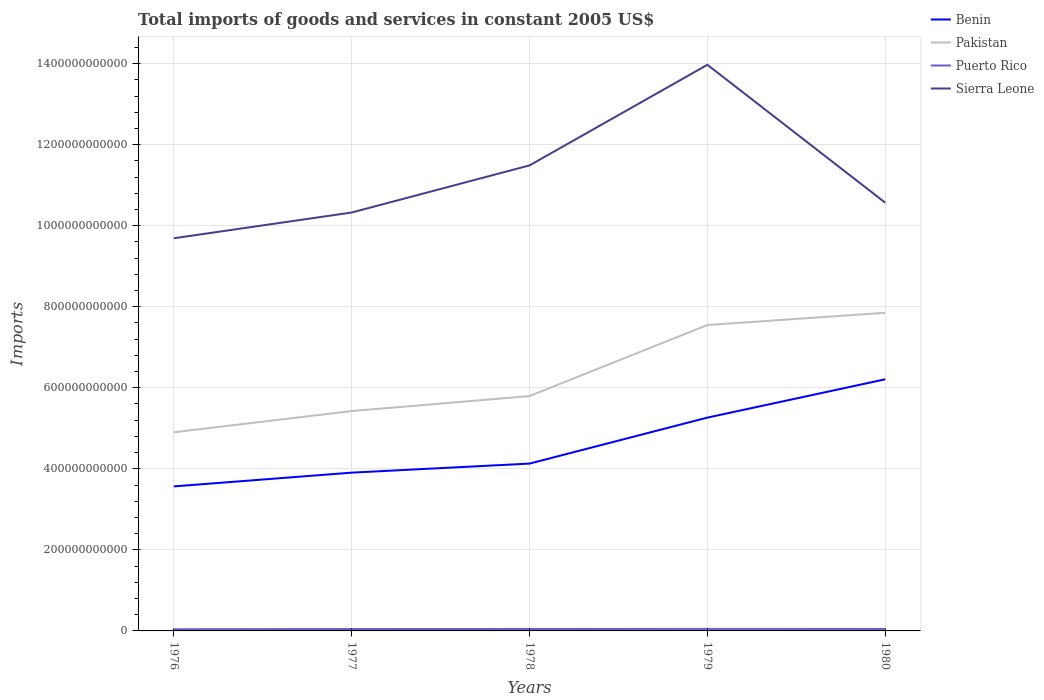How many different coloured lines are there?
Your response must be concise. 4. Does the line corresponding to Puerto Rico intersect with the line corresponding to Benin?
Offer a terse response. No. Is the number of lines equal to the number of legend labels?
Offer a terse response. Yes. Across all years, what is the maximum total imports of goods and services in Sierra Leone?
Ensure brevity in your answer.  9.69e+11. In which year was the total imports of goods and services in Pakistan maximum?
Your response must be concise. 1976. What is the total total imports of goods and services in Pakistan in the graph?
Keep it short and to the point. -2.43e+11. What is the difference between the highest and the second highest total imports of goods and services in Pakistan?
Keep it short and to the point. 2.95e+11. What is the difference between two consecutive major ticks on the Y-axis?
Provide a succinct answer. 2.00e+11. Are the values on the major ticks of Y-axis written in scientific E-notation?
Give a very brief answer. No. Does the graph contain any zero values?
Your answer should be very brief. No. Does the graph contain grids?
Offer a terse response. Yes. Where does the legend appear in the graph?
Make the answer very short. Top right. How many legend labels are there?
Your answer should be compact. 4. What is the title of the graph?
Ensure brevity in your answer.  Total imports of goods and services in constant 2005 US$. What is the label or title of the X-axis?
Your answer should be compact. Years. What is the label or title of the Y-axis?
Keep it short and to the point. Imports. What is the Imports in Benin in 1976?
Provide a short and direct response. 3.57e+11. What is the Imports of Pakistan in 1976?
Offer a very short reply. 4.90e+11. What is the Imports of Puerto Rico in 1976?
Provide a succinct answer. 4.13e+09. What is the Imports of Sierra Leone in 1976?
Provide a short and direct response. 9.69e+11. What is the Imports of Benin in 1977?
Provide a succinct answer. 3.91e+11. What is the Imports in Pakistan in 1977?
Your response must be concise. 5.43e+11. What is the Imports in Puerto Rico in 1977?
Offer a very short reply. 4.71e+09. What is the Imports in Sierra Leone in 1977?
Your answer should be compact. 1.03e+12. What is the Imports of Benin in 1978?
Ensure brevity in your answer.  4.13e+11. What is the Imports of Pakistan in 1978?
Provide a succinct answer. 5.80e+11. What is the Imports of Puerto Rico in 1978?
Offer a terse response. 4.79e+09. What is the Imports in Sierra Leone in 1978?
Keep it short and to the point. 1.15e+12. What is the Imports of Benin in 1979?
Ensure brevity in your answer.  5.26e+11. What is the Imports in Pakistan in 1979?
Provide a succinct answer. 7.55e+11. What is the Imports in Puerto Rico in 1979?
Make the answer very short. 5.01e+09. What is the Imports of Sierra Leone in 1979?
Provide a succinct answer. 1.40e+12. What is the Imports of Benin in 1980?
Your answer should be compact. 6.21e+11. What is the Imports of Pakistan in 1980?
Your answer should be very brief. 7.85e+11. What is the Imports in Puerto Rico in 1980?
Give a very brief answer. 4.88e+09. What is the Imports of Sierra Leone in 1980?
Your response must be concise. 1.06e+12. Across all years, what is the maximum Imports of Benin?
Your response must be concise. 6.21e+11. Across all years, what is the maximum Imports in Pakistan?
Your answer should be compact. 7.85e+11. Across all years, what is the maximum Imports in Puerto Rico?
Offer a terse response. 5.01e+09. Across all years, what is the maximum Imports in Sierra Leone?
Provide a succinct answer. 1.40e+12. Across all years, what is the minimum Imports in Benin?
Your response must be concise. 3.57e+11. Across all years, what is the minimum Imports in Pakistan?
Make the answer very short. 4.90e+11. Across all years, what is the minimum Imports of Puerto Rico?
Keep it short and to the point. 4.13e+09. Across all years, what is the minimum Imports in Sierra Leone?
Make the answer very short. 9.69e+11. What is the total Imports in Benin in the graph?
Your response must be concise. 2.31e+12. What is the total Imports of Pakistan in the graph?
Your answer should be very brief. 3.15e+12. What is the total Imports in Puerto Rico in the graph?
Your answer should be very brief. 2.35e+1. What is the total Imports of Sierra Leone in the graph?
Provide a short and direct response. 5.60e+12. What is the difference between the Imports in Benin in 1976 and that in 1977?
Provide a succinct answer. -3.39e+1. What is the difference between the Imports in Pakistan in 1976 and that in 1977?
Ensure brevity in your answer.  -5.23e+1. What is the difference between the Imports in Puerto Rico in 1976 and that in 1977?
Give a very brief answer. -5.82e+08. What is the difference between the Imports of Sierra Leone in 1976 and that in 1977?
Provide a short and direct response. -6.35e+1. What is the difference between the Imports in Benin in 1976 and that in 1978?
Make the answer very short. -5.63e+1. What is the difference between the Imports in Pakistan in 1976 and that in 1978?
Offer a very short reply. -8.93e+1. What is the difference between the Imports of Puerto Rico in 1976 and that in 1978?
Your response must be concise. -6.62e+08. What is the difference between the Imports of Sierra Leone in 1976 and that in 1978?
Keep it short and to the point. -1.80e+11. What is the difference between the Imports of Benin in 1976 and that in 1979?
Offer a very short reply. -1.70e+11. What is the difference between the Imports in Pakistan in 1976 and that in 1979?
Offer a terse response. -2.65e+11. What is the difference between the Imports in Puerto Rico in 1976 and that in 1979?
Offer a terse response. -8.77e+08. What is the difference between the Imports in Sierra Leone in 1976 and that in 1979?
Your answer should be very brief. -4.28e+11. What is the difference between the Imports in Benin in 1976 and that in 1980?
Provide a succinct answer. -2.64e+11. What is the difference between the Imports of Pakistan in 1976 and that in 1980?
Offer a very short reply. -2.95e+11. What is the difference between the Imports of Puerto Rico in 1976 and that in 1980?
Give a very brief answer. -7.54e+08. What is the difference between the Imports of Sierra Leone in 1976 and that in 1980?
Offer a very short reply. -8.78e+1. What is the difference between the Imports in Benin in 1977 and that in 1978?
Your answer should be very brief. -2.23e+1. What is the difference between the Imports in Pakistan in 1977 and that in 1978?
Provide a short and direct response. -3.70e+1. What is the difference between the Imports in Puerto Rico in 1977 and that in 1978?
Your answer should be very brief. -7.99e+07. What is the difference between the Imports of Sierra Leone in 1977 and that in 1978?
Your answer should be compact. -1.16e+11. What is the difference between the Imports in Benin in 1977 and that in 1979?
Ensure brevity in your answer.  -1.36e+11. What is the difference between the Imports in Pakistan in 1977 and that in 1979?
Offer a terse response. -2.12e+11. What is the difference between the Imports in Puerto Rico in 1977 and that in 1979?
Offer a terse response. -2.95e+08. What is the difference between the Imports in Sierra Leone in 1977 and that in 1979?
Offer a very short reply. -3.65e+11. What is the difference between the Imports in Benin in 1977 and that in 1980?
Keep it short and to the point. -2.30e+11. What is the difference between the Imports of Pakistan in 1977 and that in 1980?
Give a very brief answer. -2.43e+11. What is the difference between the Imports of Puerto Rico in 1977 and that in 1980?
Your answer should be compact. -1.72e+08. What is the difference between the Imports of Sierra Leone in 1977 and that in 1980?
Offer a very short reply. -2.42e+1. What is the difference between the Imports in Benin in 1978 and that in 1979?
Provide a short and direct response. -1.13e+11. What is the difference between the Imports in Pakistan in 1978 and that in 1979?
Your response must be concise. -1.75e+11. What is the difference between the Imports in Puerto Rico in 1978 and that in 1979?
Give a very brief answer. -2.15e+08. What is the difference between the Imports of Sierra Leone in 1978 and that in 1979?
Your answer should be very brief. -2.48e+11. What is the difference between the Imports in Benin in 1978 and that in 1980?
Provide a succinct answer. -2.08e+11. What is the difference between the Imports of Pakistan in 1978 and that in 1980?
Provide a succinct answer. -2.06e+11. What is the difference between the Imports of Puerto Rico in 1978 and that in 1980?
Keep it short and to the point. -9.22e+07. What is the difference between the Imports of Sierra Leone in 1978 and that in 1980?
Your response must be concise. 9.20e+1. What is the difference between the Imports in Benin in 1979 and that in 1980?
Offer a very short reply. -9.46e+1. What is the difference between the Imports in Pakistan in 1979 and that in 1980?
Provide a succinct answer. -3.02e+1. What is the difference between the Imports of Puerto Rico in 1979 and that in 1980?
Provide a short and direct response. 1.23e+08. What is the difference between the Imports in Sierra Leone in 1979 and that in 1980?
Your response must be concise. 3.40e+11. What is the difference between the Imports in Benin in 1976 and the Imports in Pakistan in 1977?
Your answer should be very brief. -1.86e+11. What is the difference between the Imports in Benin in 1976 and the Imports in Puerto Rico in 1977?
Provide a succinct answer. 3.52e+11. What is the difference between the Imports in Benin in 1976 and the Imports in Sierra Leone in 1977?
Give a very brief answer. -6.76e+11. What is the difference between the Imports in Pakistan in 1976 and the Imports in Puerto Rico in 1977?
Provide a short and direct response. 4.86e+11. What is the difference between the Imports in Pakistan in 1976 and the Imports in Sierra Leone in 1977?
Your response must be concise. -5.42e+11. What is the difference between the Imports in Puerto Rico in 1976 and the Imports in Sierra Leone in 1977?
Keep it short and to the point. -1.03e+12. What is the difference between the Imports of Benin in 1976 and the Imports of Pakistan in 1978?
Your answer should be compact. -2.23e+11. What is the difference between the Imports in Benin in 1976 and the Imports in Puerto Rico in 1978?
Provide a short and direct response. 3.52e+11. What is the difference between the Imports of Benin in 1976 and the Imports of Sierra Leone in 1978?
Ensure brevity in your answer.  -7.92e+11. What is the difference between the Imports of Pakistan in 1976 and the Imports of Puerto Rico in 1978?
Offer a terse response. 4.85e+11. What is the difference between the Imports of Pakistan in 1976 and the Imports of Sierra Leone in 1978?
Make the answer very short. -6.59e+11. What is the difference between the Imports of Puerto Rico in 1976 and the Imports of Sierra Leone in 1978?
Offer a very short reply. -1.14e+12. What is the difference between the Imports in Benin in 1976 and the Imports in Pakistan in 1979?
Your response must be concise. -3.98e+11. What is the difference between the Imports of Benin in 1976 and the Imports of Puerto Rico in 1979?
Offer a very short reply. 3.52e+11. What is the difference between the Imports in Benin in 1976 and the Imports in Sierra Leone in 1979?
Your response must be concise. -1.04e+12. What is the difference between the Imports in Pakistan in 1976 and the Imports in Puerto Rico in 1979?
Give a very brief answer. 4.85e+11. What is the difference between the Imports in Pakistan in 1976 and the Imports in Sierra Leone in 1979?
Offer a terse response. -9.07e+11. What is the difference between the Imports of Puerto Rico in 1976 and the Imports of Sierra Leone in 1979?
Give a very brief answer. -1.39e+12. What is the difference between the Imports in Benin in 1976 and the Imports in Pakistan in 1980?
Offer a terse response. -4.28e+11. What is the difference between the Imports of Benin in 1976 and the Imports of Puerto Rico in 1980?
Your response must be concise. 3.52e+11. What is the difference between the Imports of Benin in 1976 and the Imports of Sierra Leone in 1980?
Your answer should be very brief. -7.00e+11. What is the difference between the Imports in Pakistan in 1976 and the Imports in Puerto Rico in 1980?
Give a very brief answer. 4.85e+11. What is the difference between the Imports of Pakistan in 1976 and the Imports of Sierra Leone in 1980?
Your response must be concise. -5.67e+11. What is the difference between the Imports in Puerto Rico in 1976 and the Imports in Sierra Leone in 1980?
Provide a succinct answer. -1.05e+12. What is the difference between the Imports in Benin in 1977 and the Imports in Pakistan in 1978?
Make the answer very short. -1.89e+11. What is the difference between the Imports in Benin in 1977 and the Imports in Puerto Rico in 1978?
Provide a succinct answer. 3.86e+11. What is the difference between the Imports of Benin in 1977 and the Imports of Sierra Leone in 1978?
Give a very brief answer. -7.58e+11. What is the difference between the Imports of Pakistan in 1977 and the Imports of Puerto Rico in 1978?
Your response must be concise. 5.38e+11. What is the difference between the Imports in Pakistan in 1977 and the Imports in Sierra Leone in 1978?
Your answer should be compact. -6.06e+11. What is the difference between the Imports of Puerto Rico in 1977 and the Imports of Sierra Leone in 1978?
Make the answer very short. -1.14e+12. What is the difference between the Imports of Benin in 1977 and the Imports of Pakistan in 1979?
Offer a very short reply. -3.64e+11. What is the difference between the Imports in Benin in 1977 and the Imports in Puerto Rico in 1979?
Ensure brevity in your answer.  3.86e+11. What is the difference between the Imports of Benin in 1977 and the Imports of Sierra Leone in 1979?
Your response must be concise. -1.01e+12. What is the difference between the Imports in Pakistan in 1977 and the Imports in Puerto Rico in 1979?
Offer a terse response. 5.38e+11. What is the difference between the Imports of Pakistan in 1977 and the Imports of Sierra Leone in 1979?
Ensure brevity in your answer.  -8.55e+11. What is the difference between the Imports of Puerto Rico in 1977 and the Imports of Sierra Leone in 1979?
Make the answer very short. -1.39e+12. What is the difference between the Imports in Benin in 1977 and the Imports in Pakistan in 1980?
Ensure brevity in your answer.  -3.95e+11. What is the difference between the Imports in Benin in 1977 and the Imports in Puerto Rico in 1980?
Make the answer very short. 3.86e+11. What is the difference between the Imports in Benin in 1977 and the Imports in Sierra Leone in 1980?
Provide a succinct answer. -6.66e+11. What is the difference between the Imports in Pakistan in 1977 and the Imports in Puerto Rico in 1980?
Offer a terse response. 5.38e+11. What is the difference between the Imports of Pakistan in 1977 and the Imports of Sierra Leone in 1980?
Offer a terse response. -5.14e+11. What is the difference between the Imports of Puerto Rico in 1977 and the Imports of Sierra Leone in 1980?
Your answer should be very brief. -1.05e+12. What is the difference between the Imports in Benin in 1978 and the Imports in Pakistan in 1979?
Ensure brevity in your answer.  -3.42e+11. What is the difference between the Imports of Benin in 1978 and the Imports of Puerto Rico in 1979?
Offer a terse response. 4.08e+11. What is the difference between the Imports of Benin in 1978 and the Imports of Sierra Leone in 1979?
Provide a short and direct response. -9.84e+11. What is the difference between the Imports in Pakistan in 1978 and the Imports in Puerto Rico in 1979?
Your response must be concise. 5.75e+11. What is the difference between the Imports in Pakistan in 1978 and the Imports in Sierra Leone in 1979?
Provide a succinct answer. -8.17e+11. What is the difference between the Imports of Puerto Rico in 1978 and the Imports of Sierra Leone in 1979?
Provide a succinct answer. -1.39e+12. What is the difference between the Imports of Benin in 1978 and the Imports of Pakistan in 1980?
Your response must be concise. -3.72e+11. What is the difference between the Imports in Benin in 1978 and the Imports in Puerto Rico in 1980?
Provide a succinct answer. 4.08e+11. What is the difference between the Imports of Benin in 1978 and the Imports of Sierra Leone in 1980?
Your response must be concise. -6.44e+11. What is the difference between the Imports in Pakistan in 1978 and the Imports in Puerto Rico in 1980?
Provide a succinct answer. 5.75e+11. What is the difference between the Imports in Pakistan in 1978 and the Imports in Sierra Leone in 1980?
Offer a very short reply. -4.77e+11. What is the difference between the Imports of Puerto Rico in 1978 and the Imports of Sierra Leone in 1980?
Your answer should be very brief. -1.05e+12. What is the difference between the Imports in Benin in 1979 and the Imports in Pakistan in 1980?
Offer a very short reply. -2.59e+11. What is the difference between the Imports in Benin in 1979 and the Imports in Puerto Rico in 1980?
Make the answer very short. 5.22e+11. What is the difference between the Imports in Benin in 1979 and the Imports in Sierra Leone in 1980?
Offer a very short reply. -5.30e+11. What is the difference between the Imports of Pakistan in 1979 and the Imports of Puerto Rico in 1980?
Your answer should be compact. 7.50e+11. What is the difference between the Imports in Pakistan in 1979 and the Imports in Sierra Leone in 1980?
Make the answer very short. -3.02e+11. What is the difference between the Imports of Puerto Rico in 1979 and the Imports of Sierra Leone in 1980?
Ensure brevity in your answer.  -1.05e+12. What is the average Imports in Benin per year?
Your answer should be very brief. 4.62e+11. What is the average Imports in Pakistan per year?
Your answer should be very brief. 6.30e+11. What is the average Imports of Puerto Rico per year?
Provide a short and direct response. 4.71e+09. What is the average Imports of Sierra Leone per year?
Your answer should be compact. 1.12e+12. In the year 1976, what is the difference between the Imports in Benin and Imports in Pakistan?
Your response must be concise. -1.34e+11. In the year 1976, what is the difference between the Imports of Benin and Imports of Puerto Rico?
Make the answer very short. 3.53e+11. In the year 1976, what is the difference between the Imports in Benin and Imports in Sierra Leone?
Provide a short and direct response. -6.12e+11. In the year 1976, what is the difference between the Imports in Pakistan and Imports in Puerto Rico?
Your answer should be compact. 4.86e+11. In the year 1976, what is the difference between the Imports of Pakistan and Imports of Sierra Leone?
Your answer should be compact. -4.79e+11. In the year 1976, what is the difference between the Imports in Puerto Rico and Imports in Sierra Leone?
Offer a very short reply. -9.65e+11. In the year 1977, what is the difference between the Imports in Benin and Imports in Pakistan?
Give a very brief answer. -1.52e+11. In the year 1977, what is the difference between the Imports of Benin and Imports of Puerto Rico?
Keep it short and to the point. 3.86e+11. In the year 1977, what is the difference between the Imports in Benin and Imports in Sierra Leone?
Offer a very short reply. -6.42e+11. In the year 1977, what is the difference between the Imports of Pakistan and Imports of Puerto Rico?
Make the answer very short. 5.38e+11. In the year 1977, what is the difference between the Imports in Pakistan and Imports in Sierra Leone?
Your response must be concise. -4.90e+11. In the year 1977, what is the difference between the Imports of Puerto Rico and Imports of Sierra Leone?
Provide a succinct answer. -1.03e+12. In the year 1978, what is the difference between the Imports of Benin and Imports of Pakistan?
Give a very brief answer. -1.67e+11. In the year 1978, what is the difference between the Imports of Benin and Imports of Puerto Rico?
Your response must be concise. 4.08e+11. In the year 1978, what is the difference between the Imports of Benin and Imports of Sierra Leone?
Offer a very short reply. -7.36e+11. In the year 1978, what is the difference between the Imports of Pakistan and Imports of Puerto Rico?
Provide a succinct answer. 5.75e+11. In the year 1978, what is the difference between the Imports in Pakistan and Imports in Sierra Leone?
Your answer should be very brief. -5.69e+11. In the year 1978, what is the difference between the Imports of Puerto Rico and Imports of Sierra Leone?
Keep it short and to the point. -1.14e+12. In the year 1979, what is the difference between the Imports in Benin and Imports in Pakistan?
Your answer should be very brief. -2.28e+11. In the year 1979, what is the difference between the Imports in Benin and Imports in Puerto Rico?
Keep it short and to the point. 5.21e+11. In the year 1979, what is the difference between the Imports of Benin and Imports of Sierra Leone?
Your response must be concise. -8.71e+11. In the year 1979, what is the difference between the Imports of Pakistan and Imports of Puerto Rico?
Offer a terse response. 7.50e+11. In the year 1979, what is the difference between the Imports of Pakistan and Imports of Sierra Leone?
Your answer should be very brief. -6.42e+11. In the year 1979, what is the difference between the Imports in Puerto Rico and Imports in Sierra Leone?
Give a very brief answer. -1.39e+12. In the year 1980, what is the difference between the Imports of Benin and Imports of Pakistan?
Your response must be concise. -1.64e+11. In the year 1980, what is the difference between the Imports in Benin and Imports in Puerto Rico?
Give a very brief answer. 6.16e+11. In the year 1980, what is the difference between the Imports in Benin and Imports in Sierra Leone?
Ensure brevity in your answer.  -4.36e+11. In the year 1980, what is the difference between the Imports of Pakistan and Imports of Puerto Rico?
Provide a short and direct response. 7.80e+11. In the year 1980, what is the difference between the Imports in Pakistan and Imports in Sierra Leone?
Make the answer very short. -2.72e+11. In the year 1980, what is the difference between the Imports in Puerto Rico and Imports in Sierra Leone?
Keep it short and to the point. -1.05e+12. What is the ratio of the Imports of Benin in 1976 to that in 1977?
Make the answer very short. 0.91. What is the ratio of the Imports in Pakistan in 1976 to that in 1977?
Make the answer very short. 0.9. What is the ratio of the Imports of Puerto Rico in 1976 to that in 1977?
Keep it short and to the point. 0.88. What is the ratio of the Imports of Sierra Leone in 1976 to that in 1977?
Make the answer very short. 0.94. What is the ratio of the Imports in Benin in 1976 to that in 1978?
Your response must be concise. 0.86. What is the ratio of the Imports in Pakistan in 1976 to that in 1978?
Provide a succinct answer. 0.85. What is the ratio of the Imports in Puerto Rico in 1976 to that in 1978?
Make the answer very short. 0.86. What is the ratio of the Imports of Sierra Leone in 1976 to that in 1978?
Keep it short and to the point. 0.84. What is the ratio of the Imports of Benin in 1976 to that in 1979?
Give a very brief answer. 0.68. What is the ratio of the Imports in Pakistan in 1976 to that in 1979?
Give a very brief answer. 0.65. What is the ratio of the Imports of Puerto Rico in 1976 to that in 1979?
Make the answer very short. 0.82. What is the ratio of the Imports in Sierra Leone in 1976 to that in 1979?
Ensure brevity in your answer.  0.69. What is the ratio of the Imports in Benin in 1976 to that in 1980?
Provide a succinct answer. 0.57. What is the ratio of the Imports of Pakistan in 1976 to that in 1980?
Offer a terse response. 0.62. What is the ratio of the Imports of Puerto Rico in 1976 to that in 1980?
Offer a terse response. 0.85. What is the ratio of the Imports in Sierra Leone in 1976 to that in 1980?
Offer a terse response. 0.92. What is the ratio of the Imports in Benin in 1977 to that in 1978?
Keep it short and to the point. 0.95. What is the ratio of the Imports of Pakistan in 1977 to that in 1978?
Give a very brief answer. 0.94. What is the ratio of the Imports in Puerto Rico in 1977 to that in 1978?
Give a very brief answer. 0.98. What is the ratio of the Imports in Sierra Leone in 1977 to that in 1978?
Keep it short and to the point. 0.9. What is the ratio of the Imports of Benin in 1977 to that in 1979?
Provide a succinct answer. 0.74. What is the ratio of the Imports in Pakistan in 1977 to that in 1979?
Keep it short and to the point. 0.72. What is the ratio of the Imports of Puerto Rico in 1977 to that in 1979?
Ensure brevity in your answer.  0.94. What is the ratio of the Imports of Sierra Leone in 1977 to that in 1979?
Provide a succinct answer. 0.74. What is the ratio of the Imports of Benin in 1977 to that in 1980?
Provide a succinct answer. 0.63. What is the ratio of the Imports of Pakistan in 1977 to that in 1980?
Offer a terse response. 0.69. What is the ratio of the Imports in Puerto Rico in 1977 to that in 1980?
Your answer should be compact. 0.96. What is the ratio of the Imports in Sierra Leone in 1977 to that in 1980?
Your answer should be compact. 0.98. What is the ratio of the Imports of Benin in 1978 to that in 1979?
Keep it short and to the point. 0.78. What is the ratio of the Imports in Pakistan in 1978 to that in 1979?
Make the answer very short. 0.77. What is the ratio of the Imports in Puerto Rico in 1978 to that in 1979?
Offer a very short reply. 0.96. What is the ratio of the Imports in Sierra Leone in 1978 to that in 1979?
Make the answer very short. 0.82. What is the ratio of the Imports in Benin in 1978 to that in 1980?
Provide a succinct answer. 0.66. What is the ratio of the Imports in Pakistan in 1978 to that in 1980?
Provide a short and direct response. 0.74. What is the ratio of the Imports in Puerto Rico in 1978 to that in 1980?
Offer a very short reply. 0.98. What is the ratio of the Imports of Sierra Leone in 1978 to that in 1980?
Your answer should be compact. 1.09. What is the ratio of the Imports of Benin in 1979 to that in 1980?
Your response must be concise. 0.85. What is the ratio of the Imports in Pakistan in 1979 to that in 1980?
Your answer should be very brief. 0.96. What is the ratio of the Imports of Puerto Rico in 1979 to that in 1980?
Offer a terse response. 1.03. What is the ratio of the Imports in Sierra Leone in 1979 to that in 1980?
Provide a succinct answer. 1.32. What is the difference between the highest and the second highest Imports of Benin?
Provide a short and direct response. 9.46e+1. What is the difference between the highest and the second highest Imports of Pakistan?
Provide a short and direct response. 3.02e+1. What is the difference between the highest and the second highest Imports in Puerto Rico?
Keep it short and to the point. 1.23e+08. What is the difference between the highest and the second highest Imports in Sierra Leone?
Your response must be concise. 2.48e+11. What is the difference between the highest and the lowest Imports of Benin?
Keep it short and to the point. 2.64e+11. What is the difference between the highest and the lowest Imports in Pakistan?
Your answer should be compact. 2.95e+11. What is the difference between the highest and the lowest Imports of Puerto Rico?
Provide a short and direct response. 8.77e+08. What is the difference between the highest and the lowest Imports in Sierra Leone?
Offer a very short reply. 4.28e+11. 